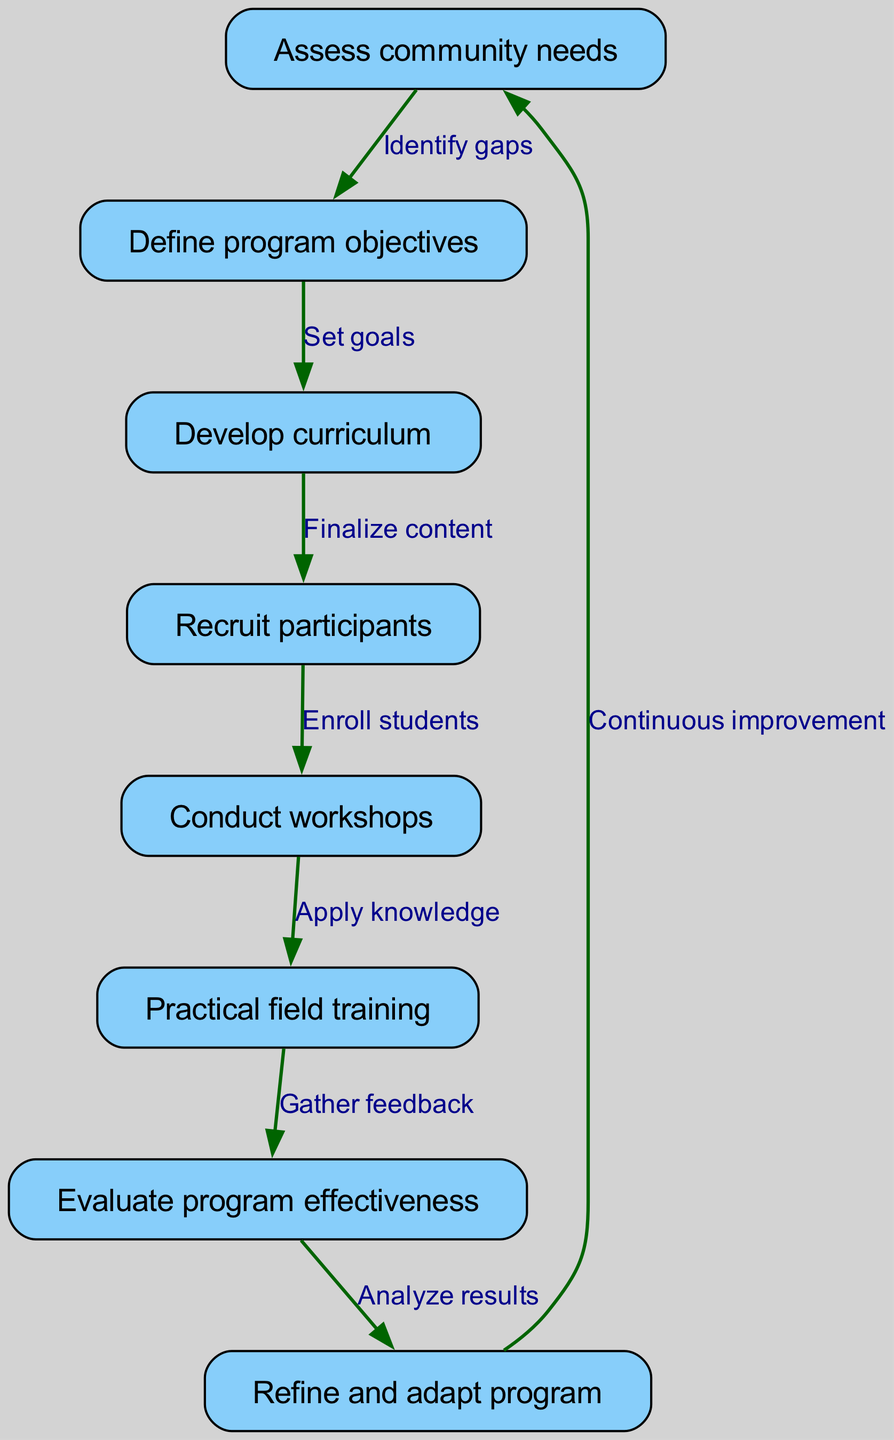What is the first step in the process? The first step according to the diagram is "Assess community needs" as it is the initial node in the flowchart.
Answer: Assess community needs How many nodes are present in the diagram? There are eight distinct nodes listed in the diagram that correspond to different steps in the process.
Answer: Eight What is the relationship between "Define program objectives" and "Develop curriculum"? The relationship is indicated by the edge stating "Set goals" connecting these two nodes, meaning that defining program objectives leads to curriculum development.
Answer: Set goals Which step comes after "Conduct workshops"? The next step after "Conduct workshops" is "Practical field training" as indicated by the edge connecting these two nodes.
Answer: Practical field training What is done after evaluating the program's effectiveness? After evaluating effectiveness, the program is "Refined and adapted" according to the flow indicated by the path from "Evaluate program effectiveness" to "Refine and adapt program."
Answer: Refine and adapt program How does the loop from "Refine and adapt program" to "Assess community needs" contribute to the educational program? This loop indicates that there is a process of continuous improvement where insights gained from the evaluation are used to reassess community needs—ensuring that the educational program remains relevant and effective over time.
Answer: Continuous improvement What connects "Recruit participants" to "Conduct workshops"? The edge connecting these two nodes states "Enroll students," which signifies that recruitment must occur before the workshops can be conducted.
Answer: Enroll students Identify the last node in the process. The last node in the process, as shown, is "Refine and adapt program," which signifies the concluding action before re-assessment of community needs.
Answer: Refine and adapt program 